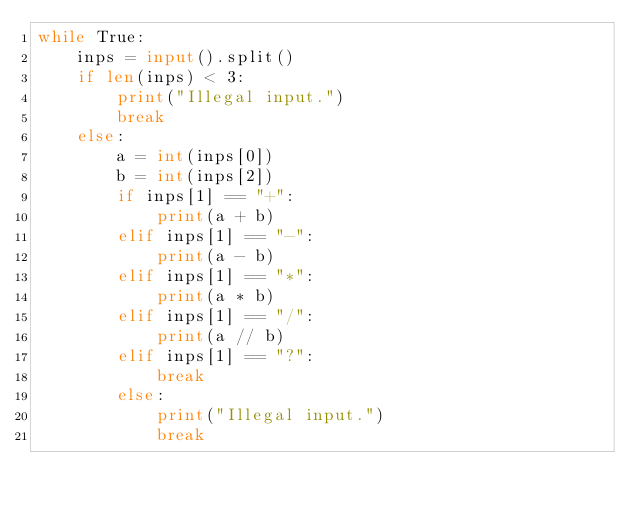<code> <loc_0><loc_0><loc_500><loc_500><_Python_>while True:
    inps = input().split()
    if len(inps) < 3:
        print("Illegal input.")
        break
    else:
        a = int(inps[0])
        b = int(inps[2])
        if inps[1] == "+":
            print(a + b)
        elif inps[1] == "-":
            print(a - b)
        elif inps[1] == "*":
            print(a * b)
        elif inps[1] == "/":
            print(a // b)
        elif inps[1] == "?":
            break
        else:
            print("Illegal input.")
            break</code> 